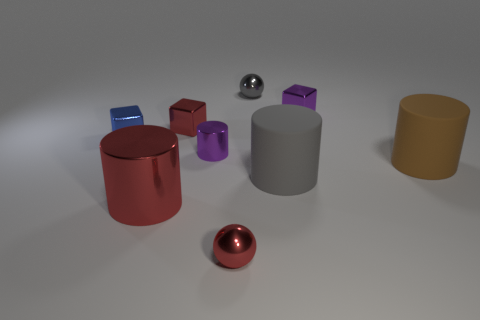Add 1 big metal cylinders. How many objects exist? 10 Subtract all spheres. How many objects are left? 7 Subtract 0 brown spheres. How many objects are left? 9 Subtract all big brown cylinders. Subtract all small blue things. How many objects are left? 7 Add 8 small blue blocks. How many small blue blocks are left? 9 Add 4 small red metallic balls. How many small red metallic balls exist? 5 